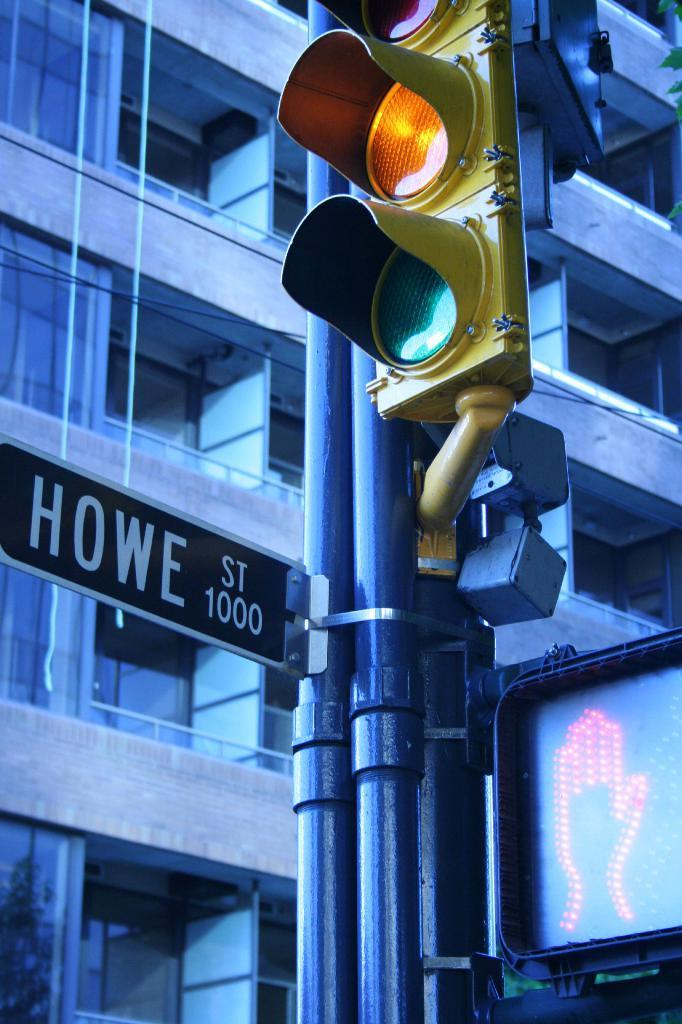<image>
Summarize the visual content of the image. A sign for Howe Street hangs near a traffic light. 